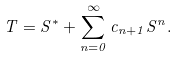Convert formula to latex. <formula><loc_0><loc_0><loc_500><loc_500>T = S ^ { * } + \sum _ { n = 0 } ^ { \infty } c _ { n + 1 } S ^ { n } .</formula> 